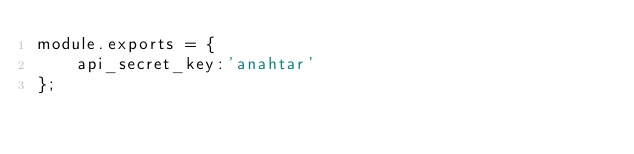Convert code to text. <code><loc_0><loc_0><loc_500><loc_500><_JavaScript_>module.exports = {
    api_secret_key:'anahtar'
};</code> 